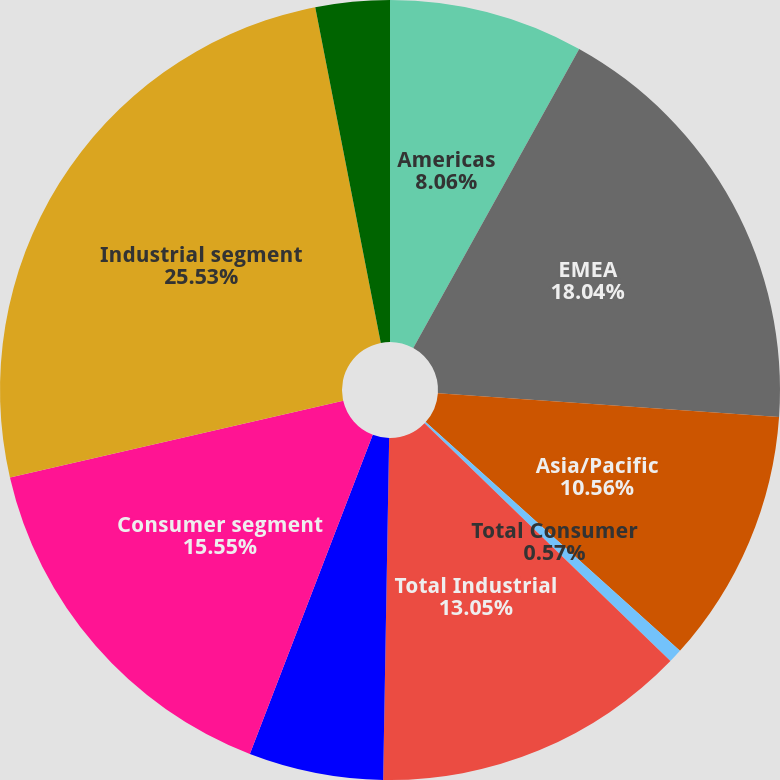Convert chart. <chart><loc_0><loc_0><loc_500><loc_500><pie_chart><fcel>Americas<fcel>EMEA<fcel>Asia/Pacific<fcel>Total Consumer<fcel>Total Industrial<fcel>Total net sales<fcel>Consumer segment<fcel>Industrial segment<fcel>Total adjusted operating<nl><fcel>8.06%<fcel>18.04%<fcel>10.56%<fcel>0.57%<fcel>13.05%<fcel>5.57%<fcel>15.55%<fcel>25.53%<fcel>3.07%<nl></chart> 